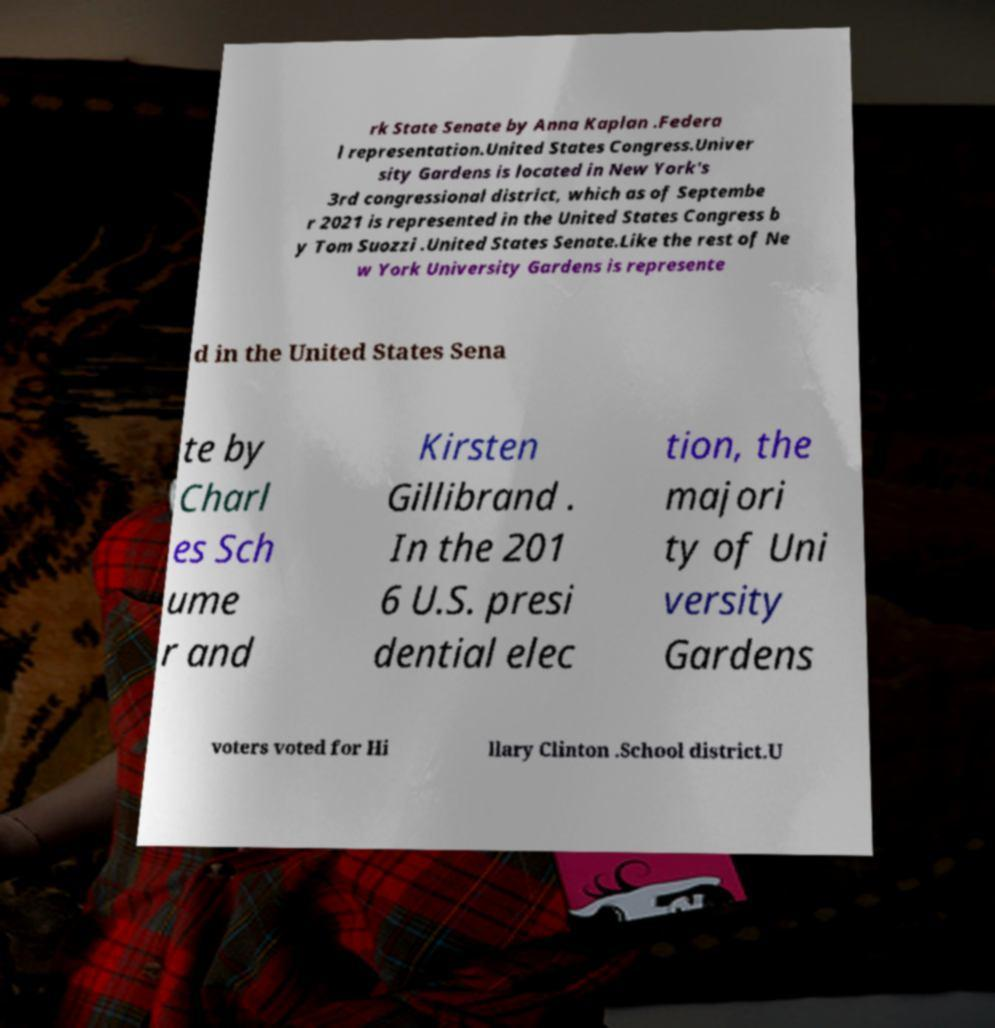Could you extract and type out the text from this image? rk State Senate by Anna Kaplan .Federa l representation.United States Congress.Univer sity Gardens is located in New York's 3rd congressional district, which as of Septembe r 2021 is represented in the United States Congress b y Tom Suozzi .United States Senate.Like the rest of Ne w York University Gardens is represente d in the United States Sena te by Charl es Sch ume r and Kirsten Gillibrand . In the 201 6 U.S. presi dential elec tion, the majori ty of Uni versity Gardens voters voted for Hi llary Clinton .School district.U 